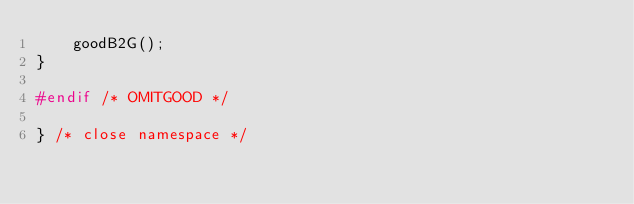Convert code to text. <code><loc_0><loc_0><loc_500><loc_500><_C++_>    goodB2G();
}

#endif /* OMITGOOD */

} /* close namespace */
</code> 